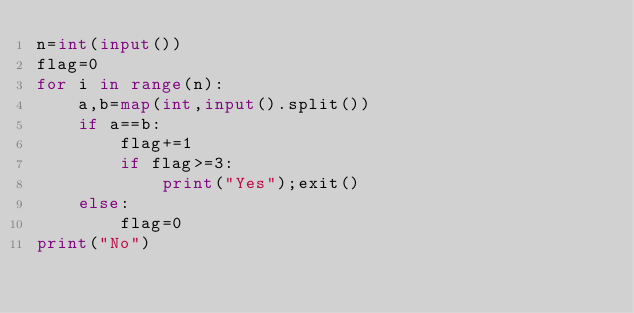<code> <loc_0><loc_0><loc_500><loc_500><_Python_>n=int(input())
flag=0
for i in range(n):
    a,b=map(int,input().split())
    if a==b:
        flag+=1
        if flag>=3:
            print("Yes");exit()
    else:
        flag=0
print("No")</code> 